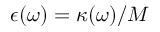Convert formula to latex. <formula><loc_0><loc_0><loc_500><loc_500>\epsilon ( \omega ) = \kappa ( \omega ) / M</formula> 